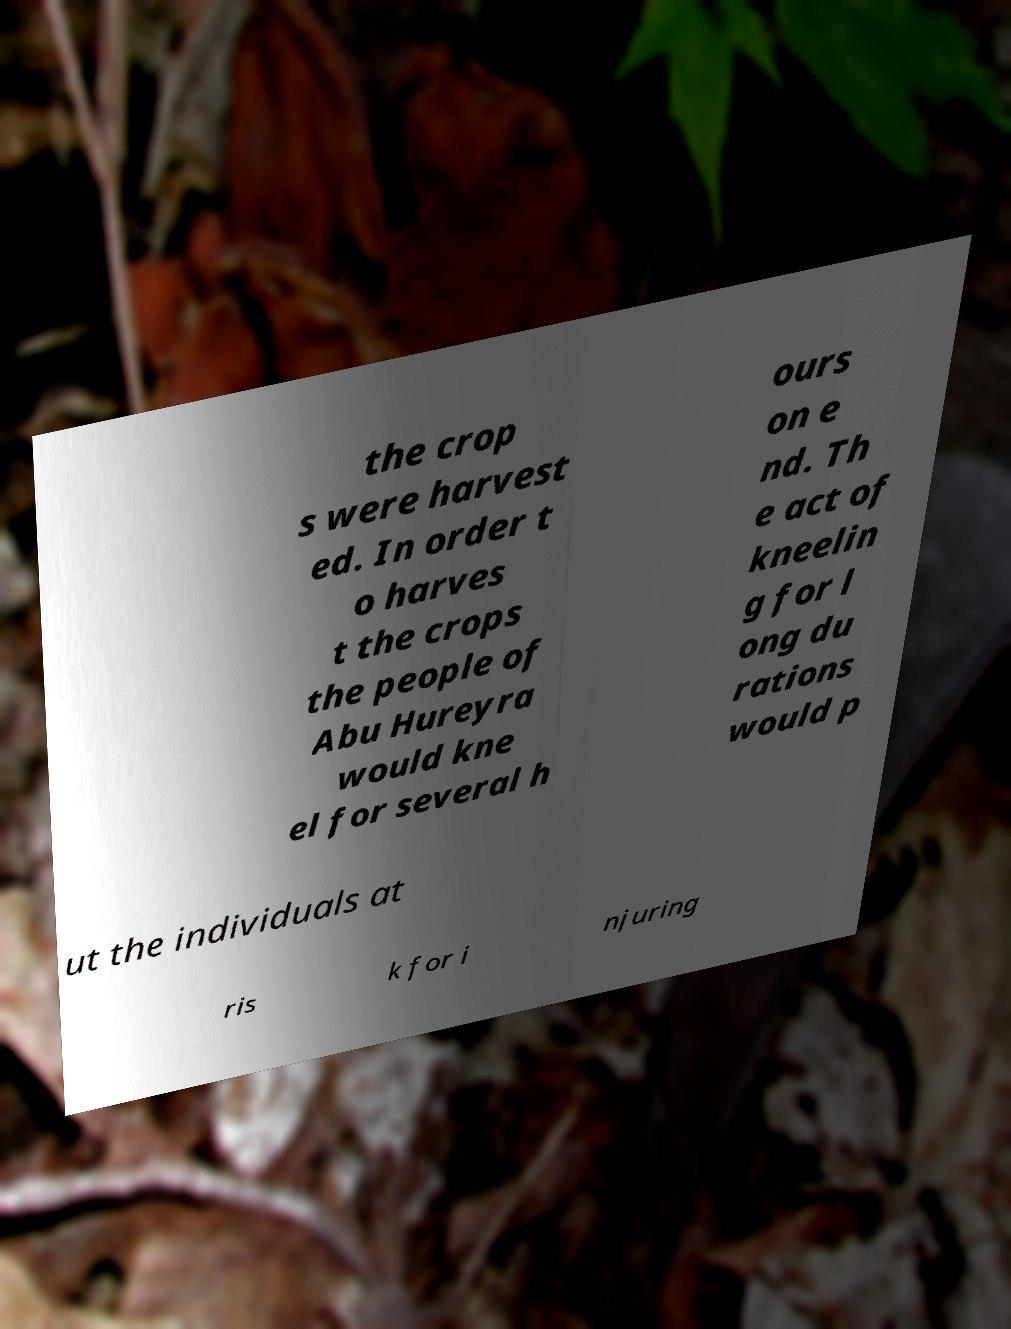Please identify and transcribe the text found in this image. the crop s were harvest ed. In order t o harves t the crops the people of Abu Hureyra would kne el for several h ours on e nd. Th e act of kneelin g for l ong du rations would p ut the individuals at ris k for i njuring 